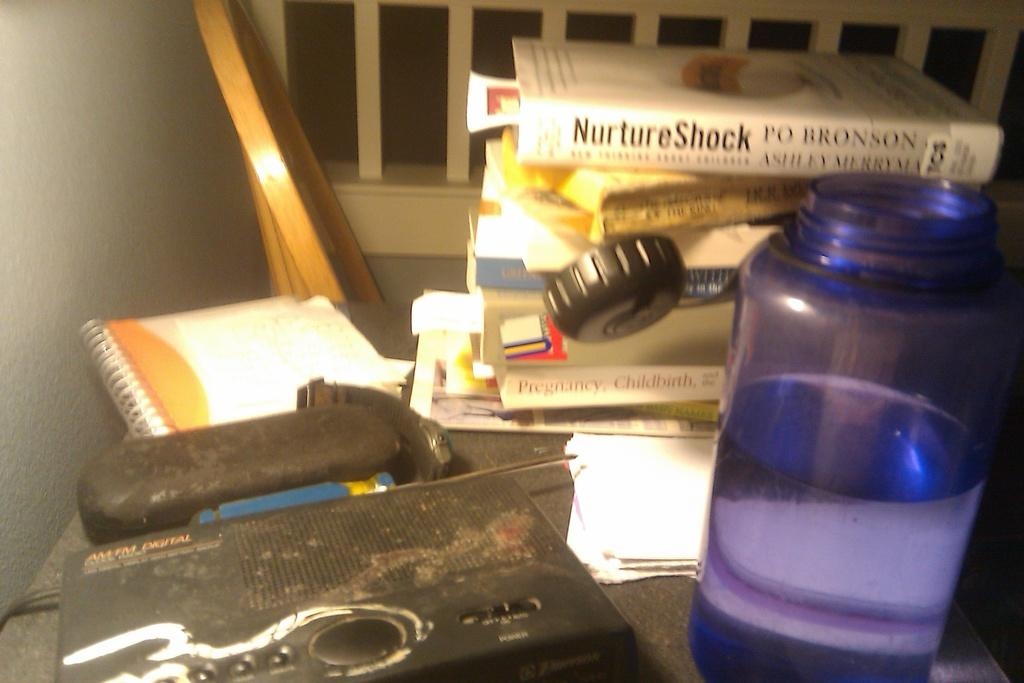<image>
Create a compact narrative representing the image presented. the word nurture is on the side of a book 